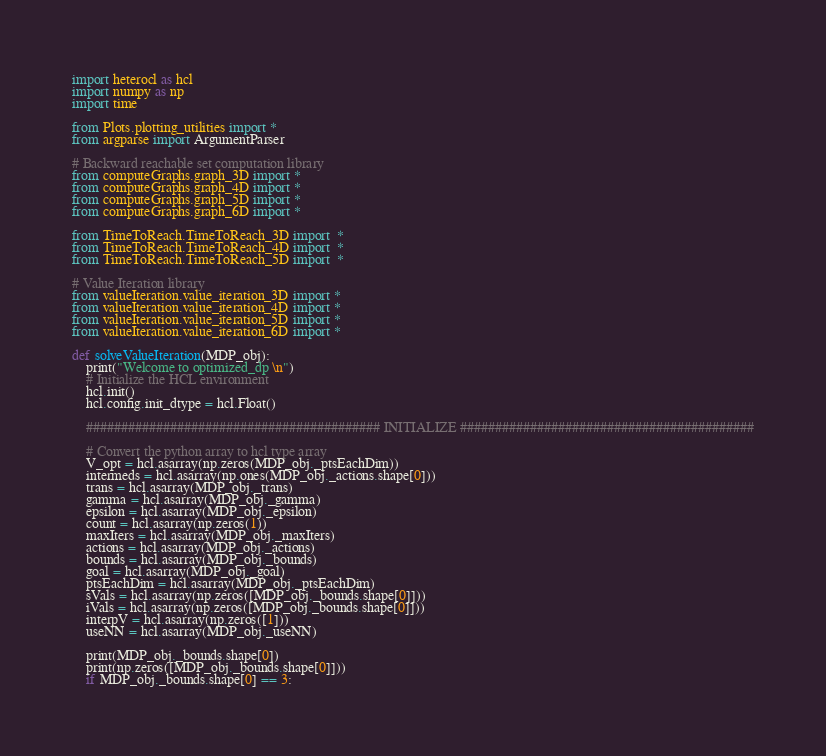Convert code to text. <code><loc_0><loc_0><loc_500><loc_500><_Python_>import heterocl as hcl
import numpy as np
import time

from Plots.plotting_utilities import *
from argparse import ArgumentParser

# Backward reachable set computation library
from computeGraphs.graph_3D import *
from computeGraphs.graph_4D import *
from computeGraphs.graph_5D import *
from computeGraphs.graph_6D import *

from TimeToReach.TimeToReach_3D import  *
from TimeToReach.TimeToReach_4D import  *
from TimeToReach.TimeToReach_5D import  *

# Value Iteration library
from valueIteration.value_iteration_3D import *
from valueIteration.value_iteration_4D import *
from valueIteration.value_iteration_5D import *
from valueIteration.value_iteration_6D import *

def solveValueIteration(MDP_obj):
    print("Welcome to optimized_dp \n")
    # Initialize the HCL environment
    hcl.init()
    hcl.config.init_dtype = hcl.Float()

    ########################################## INITIALIZE ##########################################

    # Convert the python array to hcl type array
    V_opt = hcl.asarray(np.zeros(MDP_obj._ptsEachDim))
    intermeds = hcl.asarray(np.ones(MDP_obj._actions.shape[0]))
    trans = hcl.asarray(MDP_obj._trans)
    gamma = hcl.asarray(MDP_obj._gamma)
    epsilon = hcl.asarray(MDP_obj._epsilon)
    count = hcl.asarray(np.zeros(1))
    maxIters = hcl.asarray(MDP_obj._maxIters)
    actions = hcl.asarray(MDP_obj._actions)
    bounds = hcl.asarray(MDP_obj._bounds)
    goal = hcl.asarray(MDP_obj._goal)
    ptsEachDim = hcl.asarray(MDP_obj._ptsEachDim)
    sVals = hcl.asarray(np.zeros([MDP_obj._bounds.shape[0]]))
    iVals = hcl.asarray(np.zeros([MDP_obj._bounds.shape[0]]))
    interpV = hcl.asarray(np.zeros([1]))
    useNN = hcl.asarray(MDP_obj._useNN)

    print(MDP_obj._bounds.shape[0])
    print(np.zeros([MDP_obj._bounds.shape[0]]))
    if MDP_obj._bounds.shape[0] == 3:</code> 